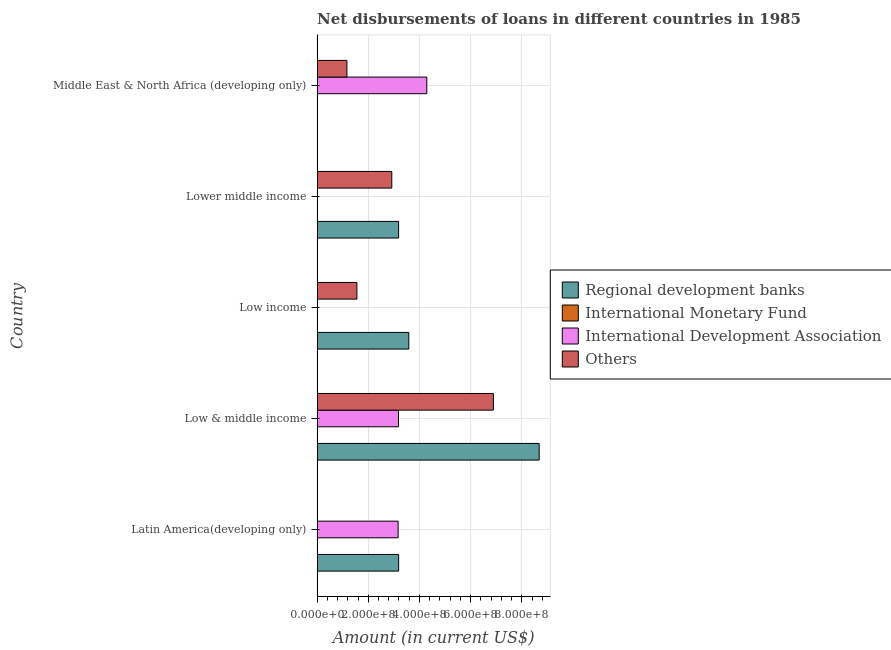How many different coloured bars are there?
Offer a very short reply. 3. Are the number of bars per tick equal to the number of legend labels?
Provide a short and direct response. No. Are the number of bars on each tick of the Y-axis equal?
Your answer should be very brief. No. What is the label of the 4th group of bars from the top?
Your answer should be very brief. Low & middle income. What is the amount of loan disimbursed by other organisations in Latin America(developing only)?
Give a very brief answer. 0. Across all countries, what is the maximum amount of loan disimbursed by other organisations?
Provide a short and direct response. 6.89e+08. Across all countries, what is the minimum amount of loan disimbursed by regional development banks?
Ensure brevity in your answer.  8.91e+05. In which country was the amount of loan disimbursed by international development association maximum?
Offer a terse response. Middle East & North Africa (developing only). What is the total amount of loan disimbursed by regional development banks in the graph?
Make the answer very short. 1.86e+09. What is the difference between the amount of loan disimbursed by international development association in Latin America(developing only) and that in Middle East & North Africa (developing only)?
Provide a short and direct response. -1.12e+08. What is the difference between the amount of loan disimbursed by international development association in Low & middle income and the amount of loan disimbursed by international monetary fund in Middle East & North Africa (developing only)?
Your answer should be compact. 3.18e+08. What is the average amount of loan disimbursed by international monetary fund per country?
Keep it short and to the point. 0. What is the difference between the amount of loan disimbursed by regional development banks and amount of loan disimbursed by international development association in Latin America(developing only)?
Keep it short and to the point. 2.04e+06. In how many countries, is the amount of loan disimbursed by international monetary fund greater than 400000000 US$?
Give a very brief answer. 0. What is the ratio of the amount of loan disimbursed by regional development banks in Latin America(developing only) to that in Low & middle income?
Give a very brief answer. 0.37. Is the difference between the amount of loan disimbursed by regional development banks in Low & middle income and Lower middle income greater than the difference between the amount of loan disimbursed by other organisations in Low & middle income and Lower middle income?
Your response must be concise. Yes. What is the difference between the highest and the second highest amount of loan disimbursed by international development association?
Offer a very short reply. 1.11e+08. What is the difference between the highest and the lowest amount of loan disimbursed by regional development banks?
Provide a short and direct response. 8.67e+08. In how many countries, is the amount of loan disimbursed by international development association greater than the average amount of loan disimbursed by international development association taken over all countries?
Provide a short and direct response. 3. Is it the case that in every country, the sum of the amount of loan disimbursed by regional development banks and amount of loan disimbursed by international monetary fund is greater than the amount of loan disimbursed by international development association?
Offer a terse response. No. Are all the bars in the graph horizontal?
Keep it short and to the point. Yes. How many countries are there in the graph?
Offer a very short reply. 5. What is the difference between two consecutive major ticks on the X-axis?
Your answer should be compact. 2.00e+08. Are the values on the major ticks of X-axis written in scientific E-notation?
Offer a terse response. Yes. Does the graph contain any zero values?
Your response must be concise. Yes. What is the title of the graph?
Your answer should be compact. Net disbursements of loans in different countries in 1985. Does "Bird species" appear as one of the legend labels in the graph?
Provide a succinct answer. No. What is the Amount (in current US$) in Regional development banks in Latin America(developing only)?
Provide a succinct answer. 3.19e+08. What is the Amount (in current US$) in International Monetary Fund in Latin America(developing only)?
Make the answer very short. 0. What is the Amount (in current US$) in International Development Association in Latin America(developing only)?
Make the answer very short. 3.17e+08. What is the Amount (in current US$) in Regional development banks in Low & middle income?
Give a very brief answer. 8.68e+08. What is the Amount (in current US$) in International Monetary Fund in Low & middle income?
Provide a short and direct response. 0. What is the Amount (in current US$) in International Development Association in Low & middle income?
Ensure brevity in your answer.  3.18e+08. What is the Amount (in current US$) in Others in Low & middle income?
Offer a very short reply. 6.89e+08. What is the Amount (in current US$) in Regional development banks in Low income?
Your answer should be compact. 3.58e+08. What is the Amount (in current US$) of International Monetary Fund in Low income?
Offer a very short reply. 0. What is the Amount (in current US$) in International Development Association in Low income?
Your answer should be compact. 0. What is the Amount (in current US$) of Others in Low income?
Make the answer very short. 1.56e+08. What is the Amount (in current US$) of Regional development banks in Lower middle income?
Give a very brief answer. 3.19e+08. What is the Amount (in current US$) of International Monetary Fund in Lower middle income?
Offer a terse response. 0. What is the Amount (in current US$) in International Development Association in Lower middle income?
Your answer should be very brief. 0. What is the Amount (in current US$) of Others in Lower middle income?
Offer a very short reply. 2.92e+08. What is the Amount (in current US$) in Regional development banks in Middle East & North Africa (developing only)?
Your response must be concise. 8.91e+05. What is the Amount (in current US$) in International Development Association in Middle East & North Africa (developing only)?
Make the answer very short. 4.29e+08. What is the Amount (in current US$) of Others in Middle East & North Africa (developing only)?
Make the answer very short. 1.17e+08. Across all countries, what is the maximum Amount (in current US$) of Regional development banks?
Ensure brevity in your answer.  8.68e+08. Across all countries, what is the maximum Amount (in current US$) in International Development Association?
Your answer should be compact. 4.29e+08. Across all countries, what is the maximum Amount (in current US$) in Others?
Your answer should be very brief. 6.89e+08. Across all countries, what is the minimum Amount (in current US$) in Regional development banks?
Offer a very short reply. 8.91e+05. Across all countries, what is the minimum Amount (in current US$) of International Development Association?
Offer a very short reply. 0. Across all countries, what is the minimum Amount (in current US$) of Others?
Keep it short and to the point. 0. What is the total Amount (in current US$) in Regional development banks in the graph?
Give a very brief answer. 1.86e+09. What is the total Amount (in current US$) in International Monetary Fund in the graph?
Ensure brevity in your answer.  0. What is the total Amount (in current US$) in International Development Association in the graph?
Offer a very short reply. 1.06e+09. What is the total Amount (in current US$) of Others in the graph?
Offer a terse response. 1.25e+09. What is the difference between the Amount (in current US$) in Regional development banks in Latin America(developing only) and that in Low & middle income?
Offer a very short reply. -5.49e+08. What is the difference between the Amount (in current US$) of International Development Association in Latin America(developing only) and that in Low & middle income?
Your answer should be very brief. -1.49e+06. What is the difference between the Amount (in current US$) of Regional development banks in Latin America(developing only) and that in Low income?
Offer a terse response. -3.97e+07. What is the difference between the Amount (in current US$) in Regional development banks in Latin America(developing only) and that in Lower middle income?
Offer a terse response. 9.50e+04. What is the difference between the Amount (in current US$) in Regional development banks in Latin America(developing only) and that in Middle East & North Africa (developing only)?
Make the answer very short. 3.18e+08. What is the difference between the Amount (in current US$) in International Development Association in Latin America(developing only) and that in Middle East & North Africa (developing only)?
Your response must be concise. -1.12e+08. What is the difference between the Amount (in current US$) in Regional development banks in Low & middle income and that in Low income?
Ensure brevity in your answer.  5.09e+08. What is the difference between the Amount (in current US$) in Others in Low & middle income and that in Low income?
Keep it short and to the point. 5.33e+08. What is the difference between the Amount (in current US$) in Regional development banks in Low & middle income and that in Lower middle income?
Your answer should be compact. 5.49e+08. What is the difference between the Amount (in current US$) of Others in Low & middle income and that in Lower middle income?
Provide a succinct answer. 3.97e+08. What is the difference between the Amount (in current US$) of Regional development banks in Low & middle income and that in Middle East & North Africa (developing only)?
Provide a short and direct response. 8.67e+08. What is the difference between the Amount (in current US$) in International Development Association in Low & middle income and that in Middle East & North Africa (developing only)?
Your response must be concise. -1.11e+08. What is the difference between the Amount (in current US$) of Others in Low & middle income and that in Middle East & North Africa (developing only)?
Offer a very short reply. 5.72e+08. What is the difference between the Amount (in current US$) of Regional development banks in Low income and that in Lower middle income?
Provide a short and direct response. 3.98e+07. What is the difference between the Amount (in current US$) of Others in Low income and that in Lower middle income?
Your answer should be very brief. -1.36e+08. What is the difference between the Amount (in current US$) of Regional development banks in Low income and that in Middle East & North Africa (developing only)?
Provide a short and direct response. 3.58e+08. What is the difference between the Amount (in current US$) of Others in Low income and that in Middle East & North Africa (developing only)?
Keep it short and to the point. 3.91e+07. What is the difference between the Amount (in current US$) of Regional development banks in Lower middle income and that in Middle East & North Africa (developing only)?
Your response must be concise. 3.18e+08. What is the difference between the Amount (in current US$) of Others in Lower middle income and that in Middle East & North Africa (developing only)?
Your response must be concise. 1.75e+08. What is the difference between the Amount (in current US$) in Regional development banks in Latin America(developing only) and the Amount (in current US$) in International Development Association in Low & middle income?
Your answer should be compact. 5.49e+05. What is the difference between the Amount (in current US$) in Regional development banks in Latin America(developing only) and the Amount (in current US$) in Others in Low & middle income?
Ensure brevity in your answer.  -3.70e+08. What is the difference between the Amount (in current US$) of International Development Association in Latin America(developing only) and the Amount (in current US$) of Others in Low & middle income?
Provide a succinct answer. -3.72e+08. What is the difference between the Amount (in current US$) of Regional development banks in Latin America(developing only) and the Amount (in current US$) of Others in Low income?
Your response must be concise. 1.63e+08. What is the difference between the Amount (in current US$) of International Development Association in Latin America(developing only) and the Amount (in current US$) of Others in Low income?
Offer a very short reply. 1.61e+08. What is the difference between the Amount (in current US$) of Regional development banks in Latin America(developing only) and the Amount (in current US$) of Others in Lower middle income?
Provide a short and direct response. 2.67e+07. What is the difference between the Amount (in current US$) of International Development Association in Latin America(developing only) and the Amount (in current US$) of Others in Lower middle income?
Offer a terse response. 2.47e+07. What is the difference between the Amount (in current US$) in Regional development banks in Latin America(developing only) and the Amount (in current US$) in International Development Association in Middle East & North Africa (developing only)?
Your answer should be very brief. -1.10e+08. What is the difference between the Amount (in current US$) of Regional development banks in Latin America(developing only) and the Amount (in current US$) of Others in Middle East & North Africa (developing only)?
Your answer should be very brief. 2.02e+08. What is the difference between the Amount (in current US$) of International Development Association in Latin America(developing only) and the Amount (in current US$) of Others in Middle East & North Africa (developing only)?
Your answer should be compact. 2.00e+08. What is the difference between the Amount (in current US$) in Regional development banks in Low & middle income and the Amount (in current US$) in Others in Low income?
Your answer should be compact. 7.12e+08. What is the difference between the Amount (in current US$) of International Development Association in Low & middle income and the Amount (in current US$) of Others in Low income?
Offer a very short reply. 1.62e+08. What is the difference between the Amount (in current US$) in Regional development banks in Low & middle income and the Amount (in current US$) in Others in Lower middle income?
Your response must be concise. 5.76e+08. What is the difference between the Amount (in current US$) in International Development Association in Low & middle income and the Amount (in current US$) in Others in Lower middle income?
Give a very brief answer. 2.62e+07. What is the difference between the Amount (in current US$) of Regional development banks in Low & middle income and the Amount (in current US$) of International Development Association in Middle East & North Africa (developing only)?
Keep it short and to the point. 4.39e+08. What is the difference between the Amount (in current US$) of Regional development banks in Low & middle income and the Amount (in current US$) of Others in Middle East & North Africa (developing only)?
Provide a succinct answer. 7.51e+08. What is the difference between the Amount (in current US$) of International Development Association in Low & middle income and the Amount (in current US$) of Others in Middle East & North Africa (developing only)?
Your response must be concise. 2.02e+08. What is the difference between the Amount (in current US$) of Regional development banks in Low income and the Amount (in current US$) of Others in Lower middle income?
Give a very brief answer. 6.65e+07. What is the difference between the Amount (in current US$) of Regional development banks in Low income and the Amount (in current US$) of International Development Association in Middle East & North Africa (developing only)?
Provide a short and direct response. -7.03e+07. What is the difference between the Amount (in current US$) in Regional development banks in Low income and the Amount (in current US$) in Others in Middle East & North Africa (developing only)?
Your answer should be compact. 2.42e+08. What is the difference between the Amount (in current US$) in Regional development banks in Lower middle income and the Amount (in current US$) in International Development Association in Middle East & North Africa (developing only)?
Keep it short and to the point. -1.10e+08. What is the difference between the Amount (in current US$) of Regional development banks in Lower middle income and the Amount (in current US$) of Others in Middle East & North Africa (developing only)?
Offer a very short reply. 2.02e+08. What is the average Amount (in current US$) of Regional development banks per country?
Provide a short and direct response. 3.73e+08. What is the average Amount (in current US$) of International Monetary Fund per country?
Ensure brevity in your answer.  0. What is the average Amount (in current US$) of International Development Association per country?
Provide a short and direct response. 2.13e+08. What is the average Amount (in current US$) in Others per country?
Provide a succinct answer. 2.51e+08. What is the difference between the Amount (in current US$) in Regional development banks and Amount (in current US$) in International Development Association in Latin America(developing only)?
Keep it short and to the point. 2.04e+06. What is the difference between the Amount (in current US$) in Regional development banks and Amount (in current US$) in International Development Association in Low & middle income?
Give a very brief answer. 5.50e+08. What is the difference between the Amount (in current US$) of Regional development banks and Amount (in current US$) of Others in Low & middle income?
Offer a terse response. 1.79e+08. What is the difference between the Amount (in current US$) of International Development Association and Amount (in current US$) of Others in Low & middle income?
Keep it short and to the point. -3.71e+08. What is the difference between the Amount (in current US$) in Regional development banks and Amount (in current US$) in Others in Low income?
Ensure brevity in your answer.  2.03e+08. What is the difference between the Amount (in current US$) of Regional development banks and Amount (in current US$) of Others in Lower middle income?
Your response must be concise. 2.67e+07. What is the difference between the Amount (in current US$) of Regional development banks and Amount (in current US$) of International Development Association in Middle East & North Africa (developing only)?
Make the answer very short. -4.28e+08. What is the difference between the Amount (in current US$) in Regional development banks and Amount (in current US$) in Others in Middle East & North Africa (developing only)?
Give a very brief answer. -1.16e+08. What is the difference between the Amount (in current US$) of International Development Association and Amount (in current US$) of Others in Middle East & North Africa (developing only)?
Give a very brief answer. 3.12e+08. What is the ratio of the Amount (in current US$) in Regional development banks in Latin America(developing only) to that in Low & middle income?
Offer a terse response. 0.37. What is the ratio of the Amount (in current US$) of Regional development banks in Latin America(developing only) to that in Low income?
Your answer should be compact. 0.89. What is the ratio of the Amount (in current US$) in Regional development banks in Latin America(developing only) to that in Lower middle income?
Provide a succinct answer. 1. What is the ratio of the Amount (in current US$) of Regional development banks in Latin America(developing only) to that in Middle East & North Africa (developing only)?
Offer a terse response. 357.74. What is the ratio of the Amount (in current US$) in International Development Association in Latin America(developing only) to that in Middle East & North Africa (developing only)?
Provide a succinct answer. 0.74. What is the ratio of the Amount (in current US$) of Regional development banks in Low & middle income to that in Low income?
Keep it short and to the point. 2.42. What is the ratio of the Amount (in current US$) in Others in Low & middle income to that in Low income?
Your answer should be very brief. 4.42. What is the ratio of the Amount (in current US$) in Regional development banks in Low & middle income to that in Lower middle income?
Your answer should be very brief. 2.72. What is the ratio of the Amount (in current US$) in Others in Low & middle income to that in Lower middle income?
Keep it short and to the point. 2.36. What is the ratio of the Amount (in current US$) of Regional development banks in Low & middle income to that in Middle East & North Africa (developing only)?
Give a very brief answer. 974.05. What is the ratio of the Amount (in current US$) of International Development Association in Low & middle income to that in Middle East & North Africa (developing only)?
Give a very brief answer. 0.74. What is the ratio of the Amount (in current US$) of Others in Low & middle income to that in Middle East & North Africa (developing only)?
Your answer should be compact. 5.91. What is the ratio of the Amount (in current US$) of Regional development banks in Low income to that in Lower middle income?
Offer a very short reply. 1.12. What is the ratio of the Amount (in current US$) of Others in Low income to that in Lower middle income?
Give a very brief answer. 0.53. What is the ratio of the Amount (in current US$) of Regional development banks in Low income to that in Middle East & North Africa (developing only)?
Give a very brief answer. 402.3. What is the ratio of the Amount (in current US$) of Others in Low income to that in Middle East & North Africa (developing only)?
Make the answer very short. 1.34. What is the ratio of the Amount (in current US$) in Regional development banks in Lower middle income to that in Middle East & North Africa (developing only)?
Your answer should be very brief. 357.63. What is the ratio of the Amount (in current US$) of Others in Lower middle income to that in Middle East & North Africa (developing only)?
Offer a terse response. 2.5. What is the difference between the highest and the second highest Amount (in current US$) of Regional development banks?
Offer a very short reply. 5.09e+08. What is the difference between the highest and the second highest Amount (in current US$) in International Development Association?
Your answer should be very brief. 1.11e+08. What is the difference between the highest and the second highest Amount (in current US$) in Others?
Give a very brief answer. 3.97e+08. What is the difference between the highest and the lowest Amount (in current US$) of Regional development banks?
Offer a very short reply. 8.67e+08. What is the difference between the highest and the lowest Amount (in current US$) of International Development Association?
Keep it short and to the point. 4.29e+08. What is the difference between the highest and the lowest Amount (in current US$) of Others?
Offer a terse response. 6.89e+08. 